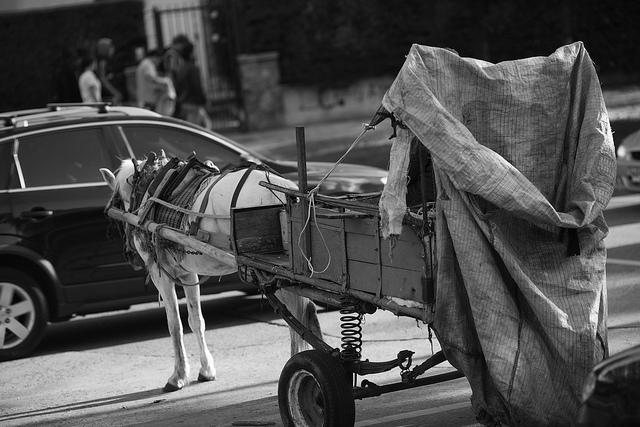Why is the animal that is hooked up to the cart doing?

Choices:
A) racing
B) eating
C) waiting
D) drinking waiting 